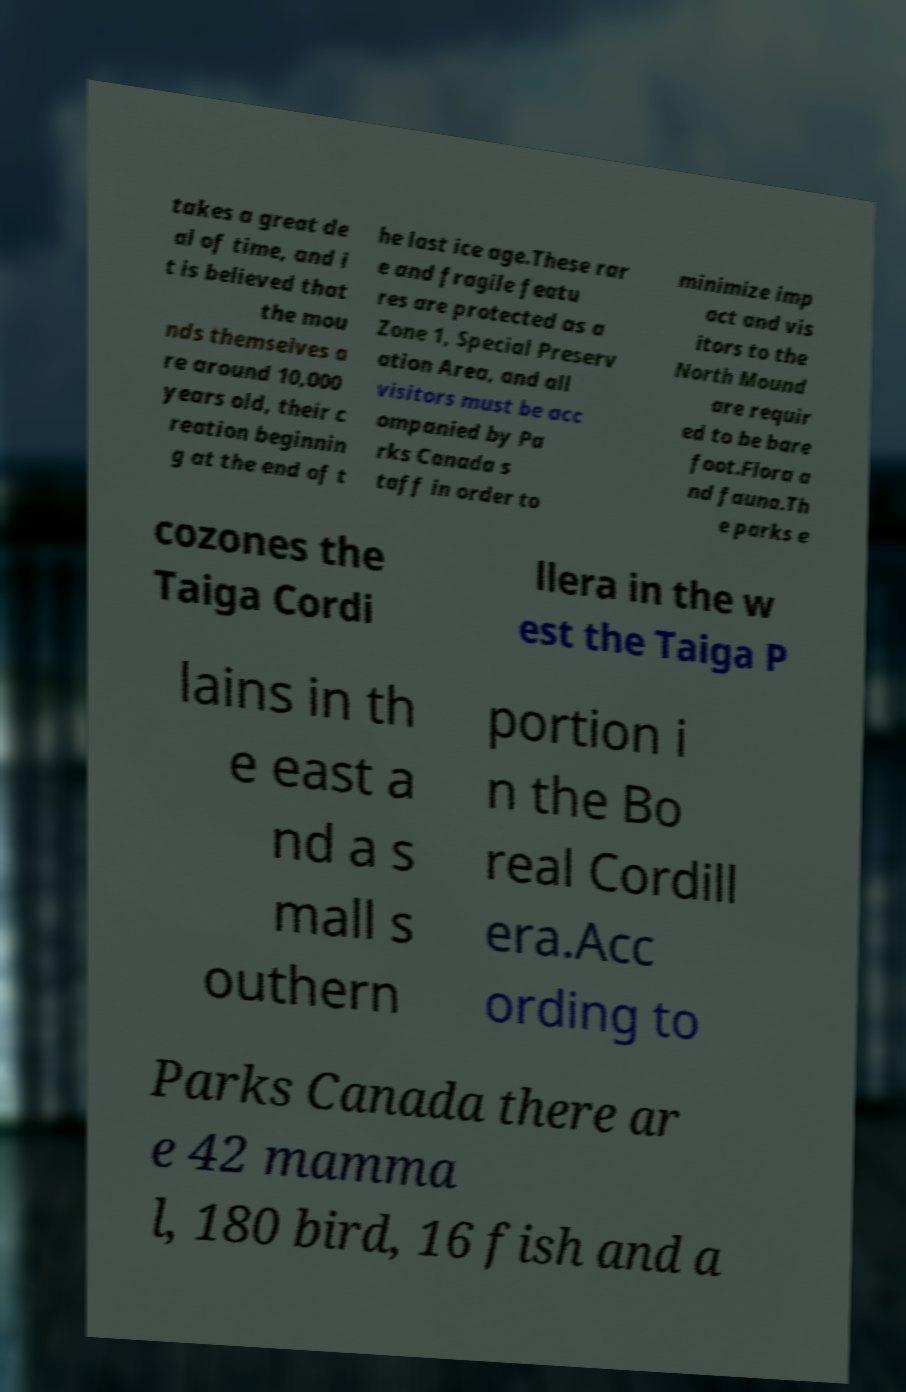Could you extract and type out the text from this image? takes a great de al of time, and i t is believed that the mou nds themselves a re around 10,000 years old, their c reation beginnin g at the end of t he last ice age.These rar e and fragile featu res are protected as a Zone 1, Special Preserv ation Area, and all visitors must be acc ompanied by Pa rks Canada s taff in order to minimize imp act and vis itors to the North Mound are requir ed to be bare foot.Flora a nd fauna.Th e parks e cozones the Taiga Cordi llera in the w est the Taiga P lains in th e east a nd a s mall s outhern portion i n the Bo real Cordill era.Acc ording to Parks Canada there ar e 42 mamma l, 180 bird, 16 fish and a 